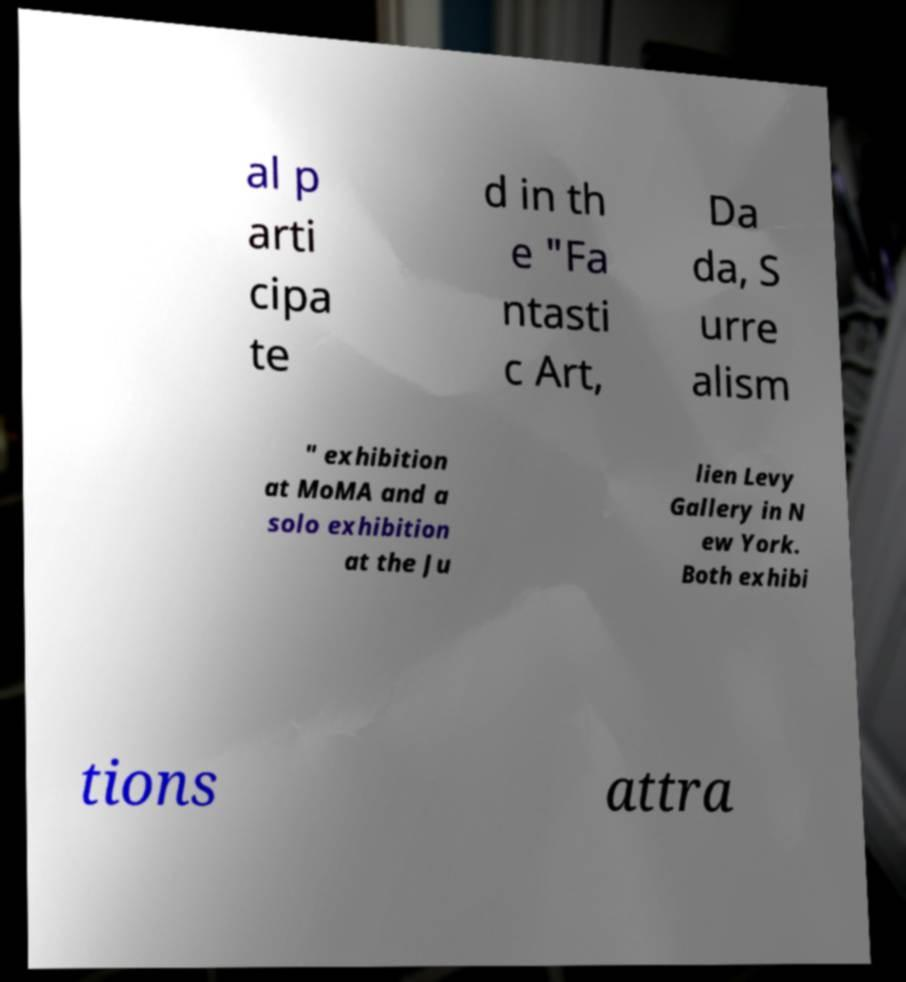What messages or text are displayed in this image? I need them in a readable, typed format. al p arti cipa te d in th e "Fa ntasti c Art, Da da, S urre alism " exhibition at MoMA and a solo exhibition at the Ju lien Levy Gallery in N ew York. Both exhibi tions attra 